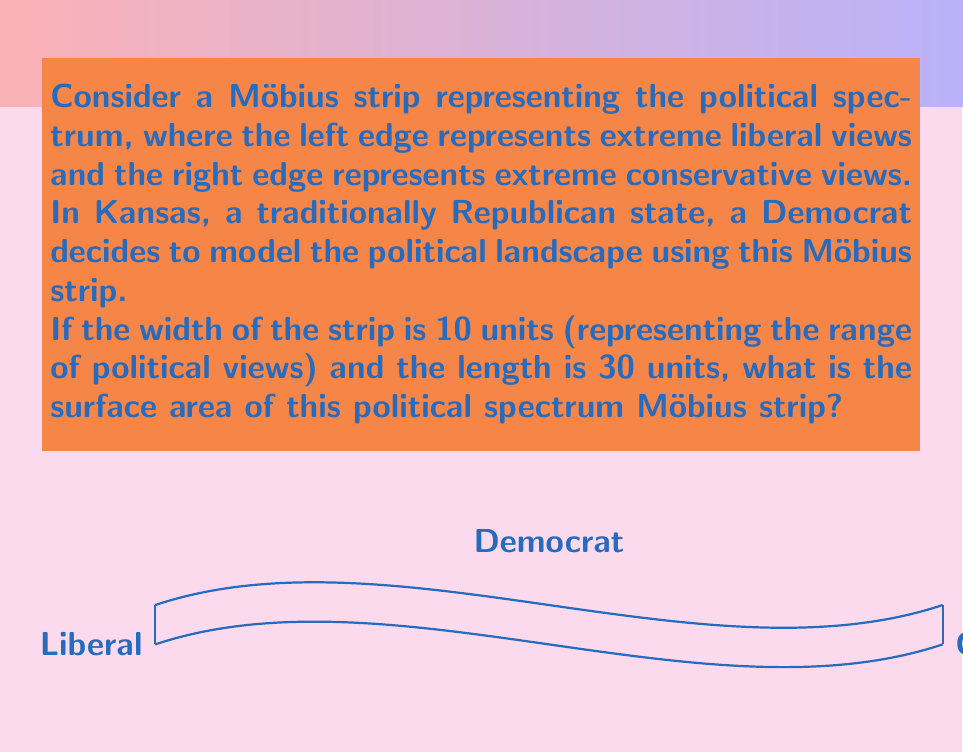Can you answer this question? Let's approach this step-by-step:

1) The formula for the surface area of a Möbius strip is:

   $$A = \frac{1}{2}lw$$

   Where $l$ is the length of the strip and $w$ is the width.

2) We are given:
   - Width (w) = 10 units
   - Length (l) = 30 units

3) Let's substitute these values into our formula:

   $$A = \frac{1}{2} \cdot 30 \cdot 10$$

4) Now we can calculate:

   $$A = \frac{1}{2} \cdot 300 = 150$$

5) Therefore, the surface area of the Möbius strip is 150 square units.

This model illustrates how the political spectrum isn't simply linear, but continuous and interconnected. The Möbius strip's unique property of having only one side and one edge represents how extreme views on both ends of the spectrum can sometimes meet, and how political ideologies can be more complex than a simple left-right divide.

For a Democrat in Kansas, this model could be particularly relevant in understanding the nuanced political landscape of a traditionally Republican state, where views might not always align with the stereotypical party positions.
Answer: 150 square units 